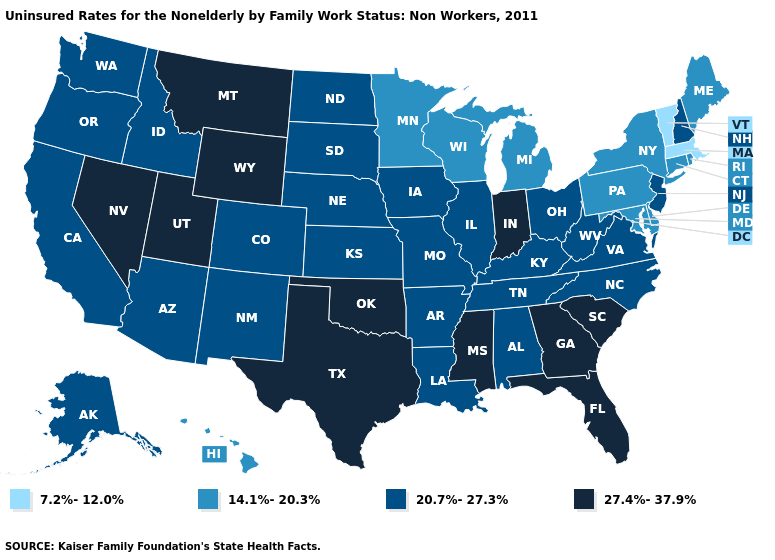What is the value of Delaware?
Short answer required. 14.1%-20.3%. Name the states that have a value in the range 14.1%-20.3%?
Keep it brief. Connecticut, Delaware, Hawaii, Maine, Maryland, Michigan, Minnesota, New York, Pennsylvania, Rhode Island, Wisconsin. What is the highest value in states that border Indiana?
Keep it brief. 20.7%-27.3%. What is the lowest value in states that border Connecticut?
Be succinct. 7.2%-12.0%. What is the value of Montana?
Be succinct. 27.4%-37.9%. Which states hav the highest value in the Northeast?
Write a very short answer. New Hampshire, New Jersey. Name the states that have a value in the range 20.7%-27.3%?
Write a very short answer. Alabama, Alaska, Arizona, Arkansas, California, Colorado, Idaho, Illinois, Iowa, Kansas, Kentucky, Louisiana, Missouri, Nebraska, New Hampshire, New Jersey, New Mexico, North Carolina, North Dakota, Ohio, Oregon, South Dakota, Tennessee, Virginia, Washington, West Virginia. What is the value of New Mexico?
Be succinct. 20.7%-27.3%. Name the states that have a value in the range 14.1%-20.3%?
Keep it brief. Connecticut, Delaware, Hawaii, Maine, Maryland, Michigan, Minnesota, New York, Pennsylvania, Rhode Island, Wisconsin. Which states have the lowest value in the Northeast?
Concise answer only. Massachusetts, Vermont. What is the highest value in the South ?
Keep it brief. 27.4%-37.9%. Name the states that have a value in the range 20.7%-27.3%?
Be succinct. Alabama, Alaska, Arizona, Arkansas, California, Colorado, Idaho, Illinois, Iowa, Kansas, Kentucky, Louisiana, Missouri, Nebraska, New Hampshire, New Jersey, New Mexico, North Carolina, North Dakota, Ohio, Oregon, South Dakota, Tennessee, Virginia, Washington, West Virginia. What is the value of New Mexico?
Write a very short answer. 20.7%-27.3%. Name the states that have a value in the range 14.1%-20.3%?
Write a very short answer. Connecticut, Delaware, Hawaii, Maine, Maryland, Michigan, Minnesota, New York, Pennsylvania, Rhode Island, Wisconsin. Among the states that border Connecticut , which have the highest value?
Short answer required. New York, Rhode Island. 